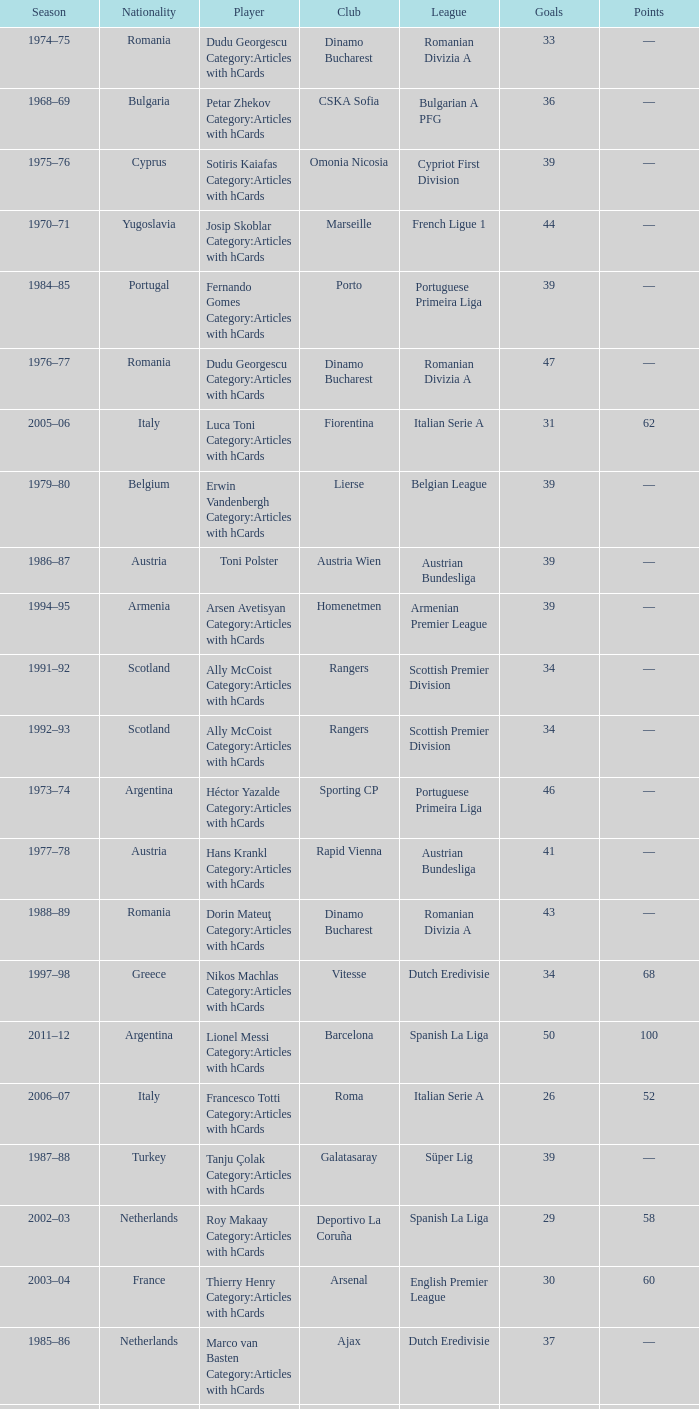Which player was in the Omonia Nicosia club? Sotiris Kaiafas Category:Articles with hCards. 